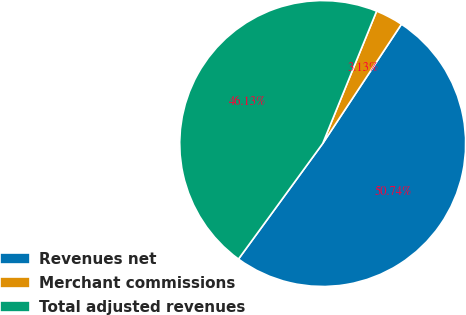Convert chart to OTSL. <chart><loc_0><loc_0><loc_500><loc_500><pie_chart><fcel>Revenues net<fcel>Merchant commissions<fcel>Total adjusted revenues<nl><fcel>50.74%<fcel>3.13%<fcel>46.13%<nl></chart> 